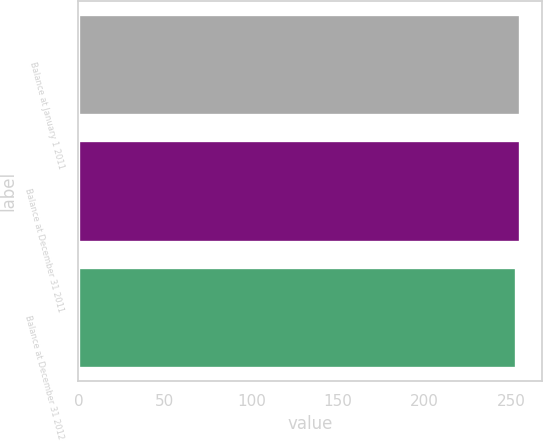Convert chart. <chart><loc_0><loc_0><loc_500><loc_500><bar_chart><fcel>Balance at January 1 2011<fcel>Balance at December 31 2011<fcel>Balance at December 31 2012<nl><fcel>255<fcel>255.2<fcel>253<nl></chart> 